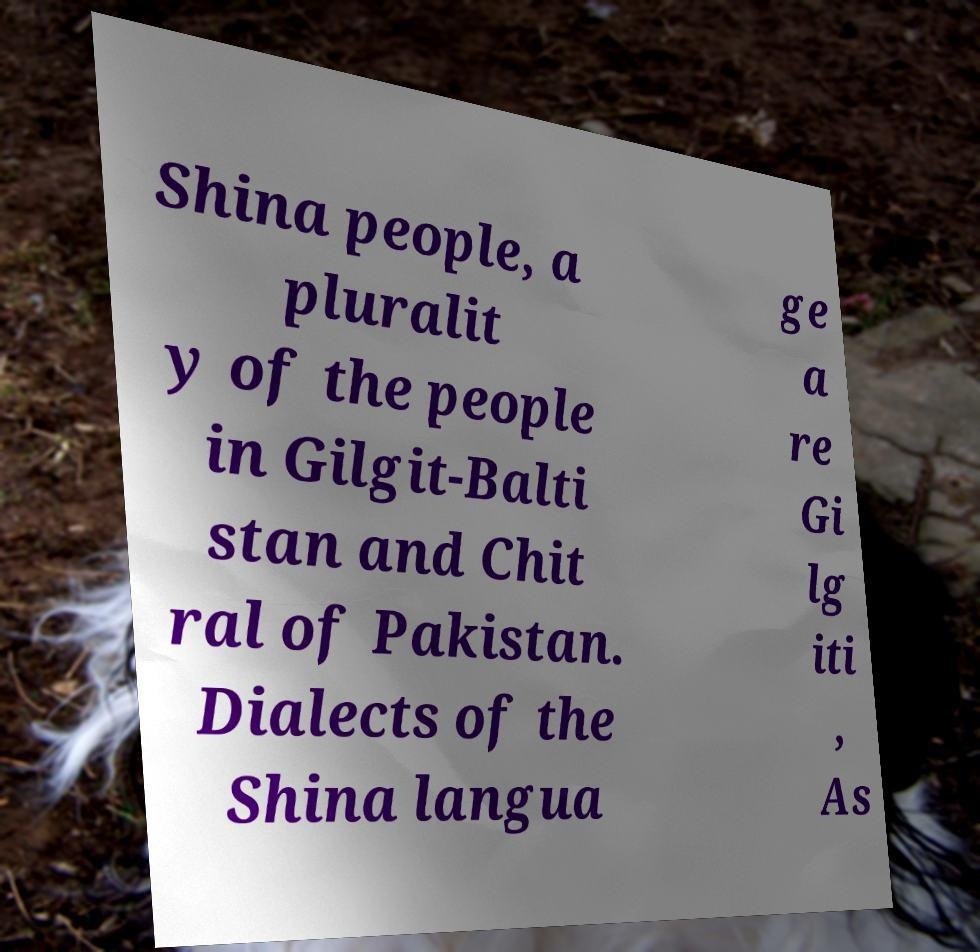Could you assist in decoding the text presented in this image and type it out clearly? Shina people, a pluralit y of the people in Gilgit-Balti stan and Chit ral of Pakistan. Dialects of the Shina langua ge a re Gi lg iti , As 